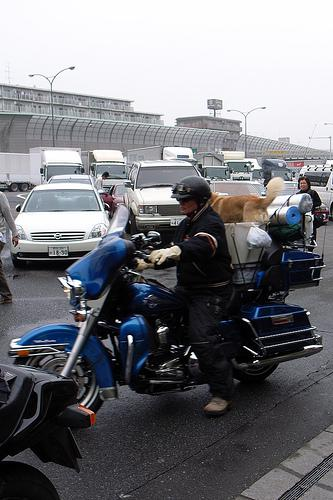Question: where is this location?
Choices:
A. A street.
B. Inside a house.
C. Parking lot.
D. In a tunnel.
Answer with the letter. Answer: C Question: what is in the background?
Choices:
A. A castle.
B. Trucks.
C. A billboard.
D. A sign.
Answer with the letter. Answer: B Question: where are the trucks parked?
Choices:
A. At a rest area.
B. At a truck stop.
C. In the parking garage.
D. Near building.
Answer with the letter. Answer: D Question: what is the man sitting on?
Choices:
A. A chair.
B. The table.
C. A couch.
D. Motorcycle.
Answer with the letter. Answer: D 